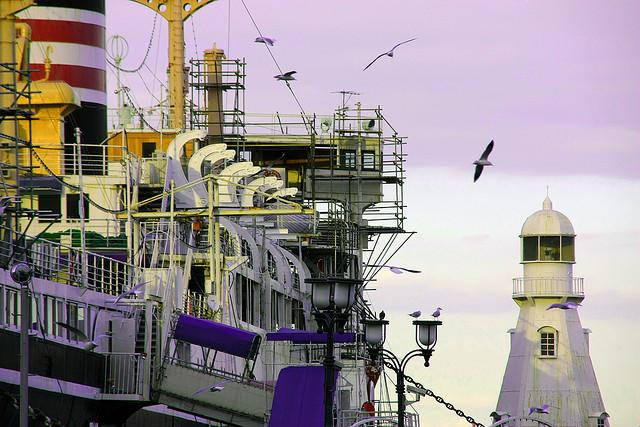How many kind of ships available mostly? Please explain your reasoning. seven. There are seven major types of ships. 